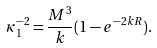<formula> <loc_0><loc_0><loc_500><loc_500>\kappa _ { 1 } ^ { - 2 } = \frac { M ^ { 3 } } { k } ( 1 - e ^ { - 2 k R } ) .</formula> 